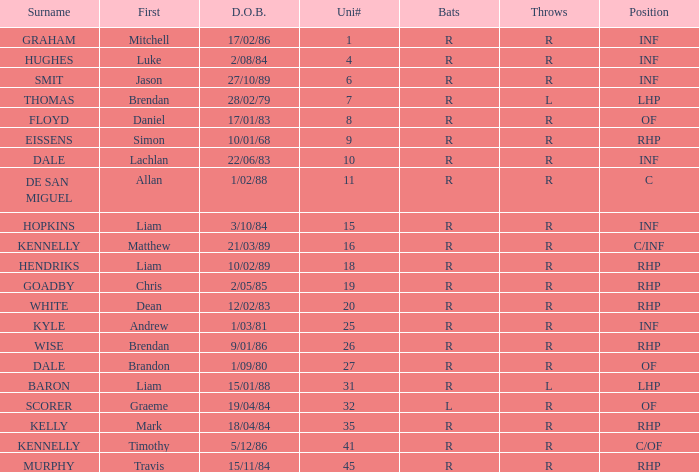Which offensive player has a uni# of 31? R. 